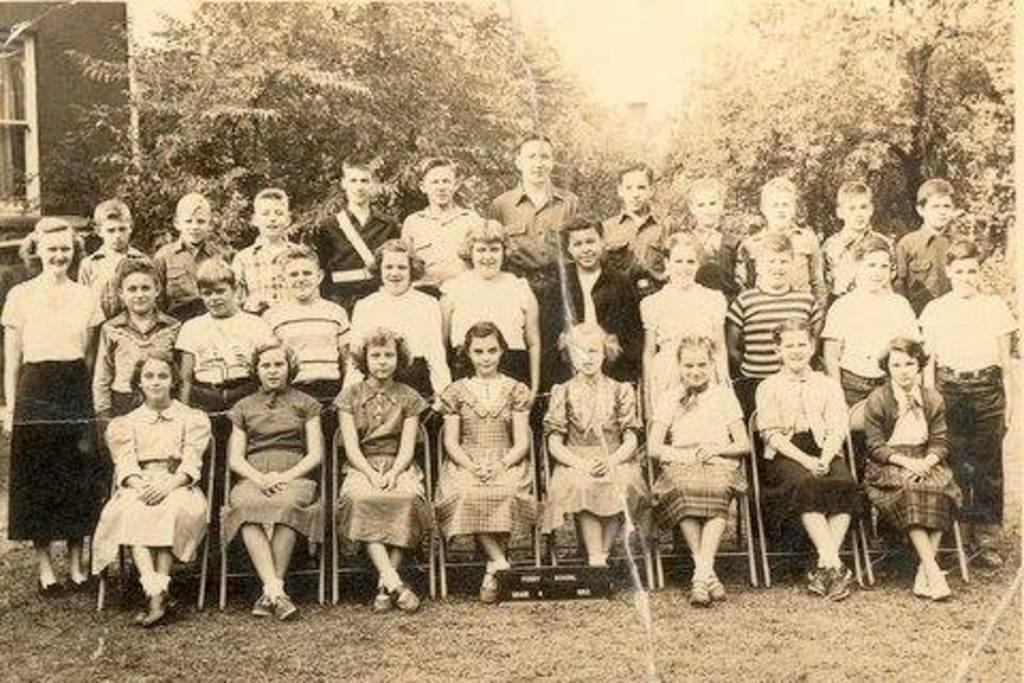What is the color scheme of the image? The image is in black and white. What type of natural elements can be seen in the image? There are trees in the image. What type of man-made structures are present in the image? There are buildings in the image. What are some of the people in the image doing? Some people are standing, and some are sitting on chairs in the image. What is visible at the bottom of the image? There is ground visible at the bottom of the image. What type of lock is being used to secure the trees in the image? There is no lock present in the image, and the trees are not being secured. Can you tell me how many people are flying in the image? There are no people flying in the image; they are either standing or sitting on chairs. 